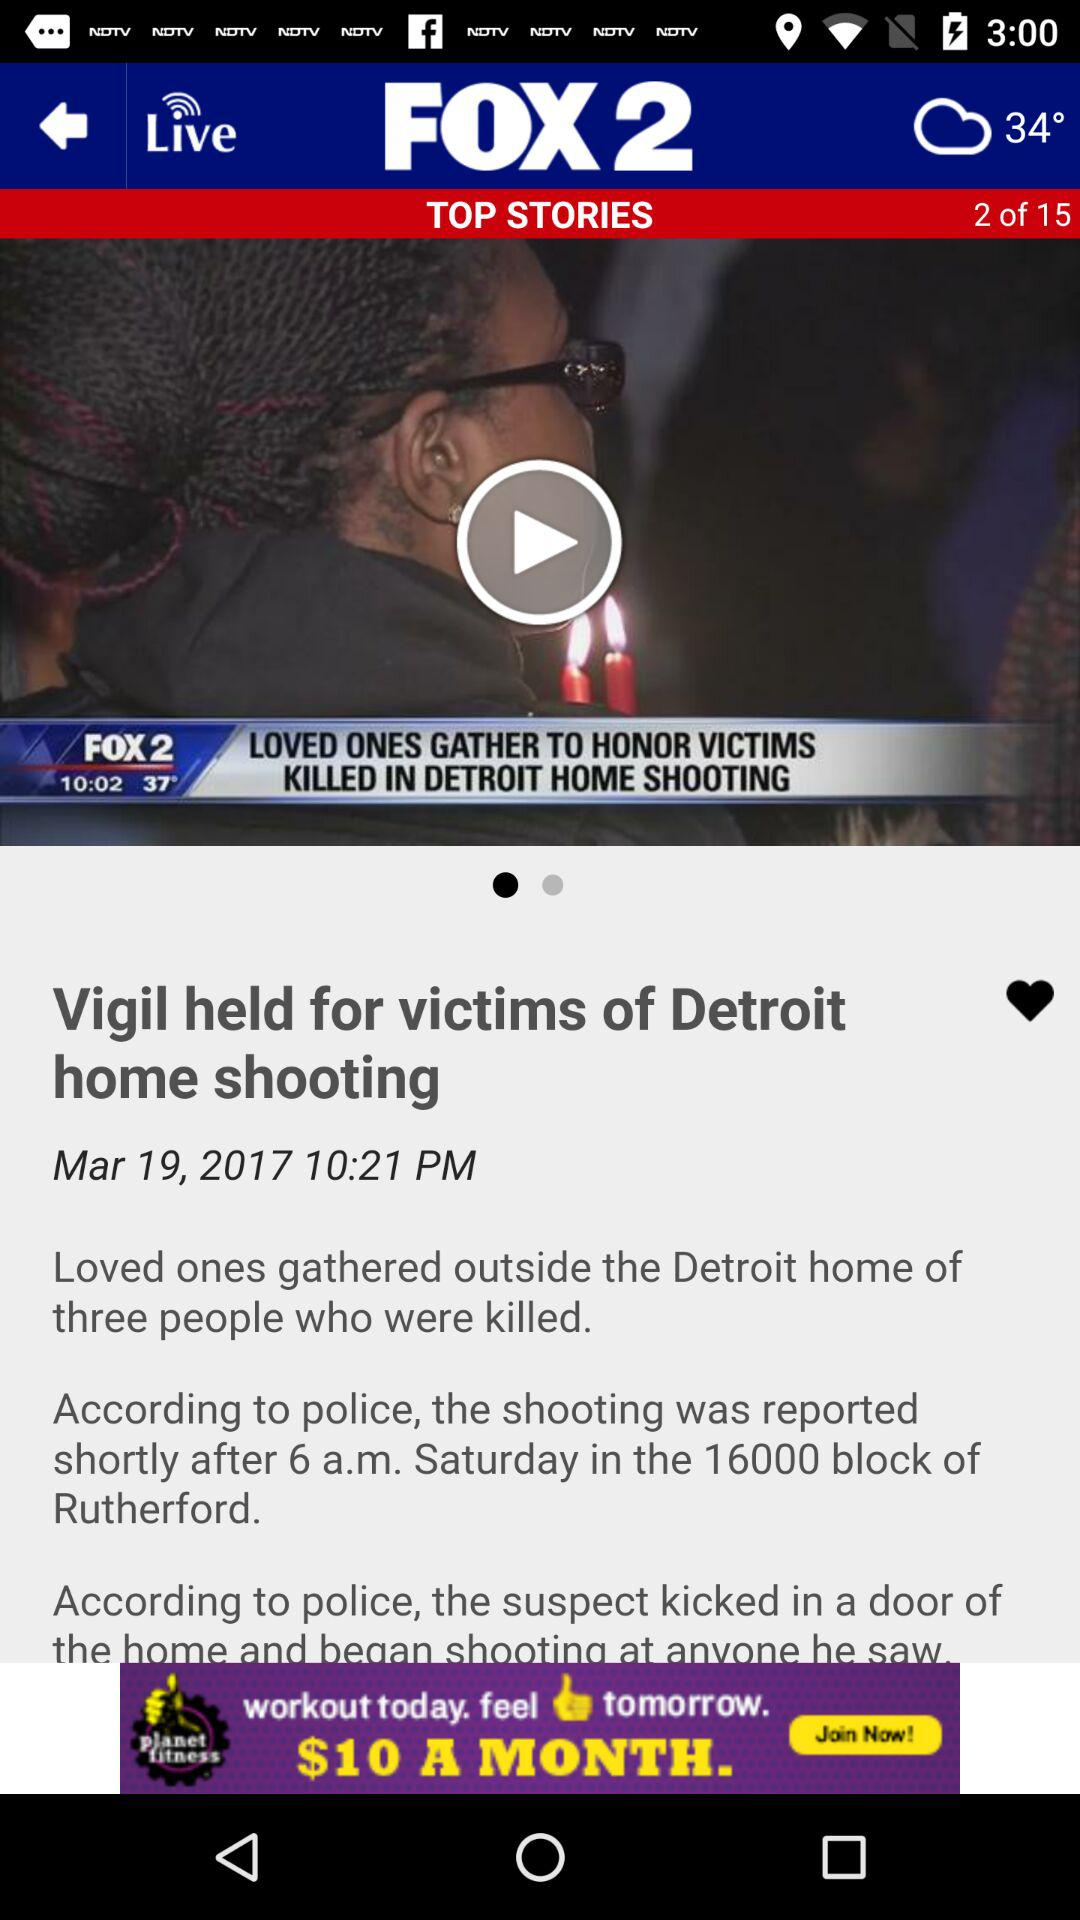What is the publication date of the article? The publication date of the article is 19 March, 2017. 